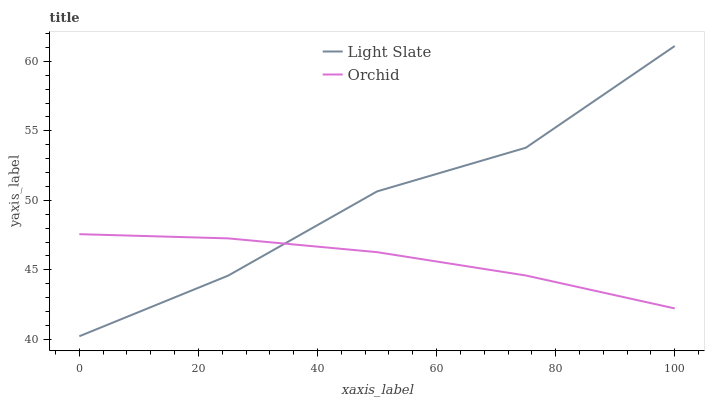Does Orchid have the minimum area under the curve?
Answer yes or no. Yes. Does Light Slate have the maximum area under the curve?
Answer yes or no. Yes. Does Orchid have the maximum area under the curve?
Answer yes or no. No. Is Orchid the smoothest?
Answer yes or no. Yes. Is Light Slate the roughest?
Answer yes or no. Yes. Is Orchid the roughest?
Answer yes or no. No. Does Light Slate have the lowest value?
Answer yes or no. Yes. Does Orchid have the lowest value?
Answer yes or no. No. Does Light Slate have the highest value?
Answer yes or no. Yes. Does Orchid have the highest value?
Answer yes or no. No. Does Light Slate intersect Orchid?
Answer yes or no. Yes. Is Light Slate less than Orchid?
Answer yes or no. No. Is Light Slate greater than Orchid?
Answer yes or no. No. 